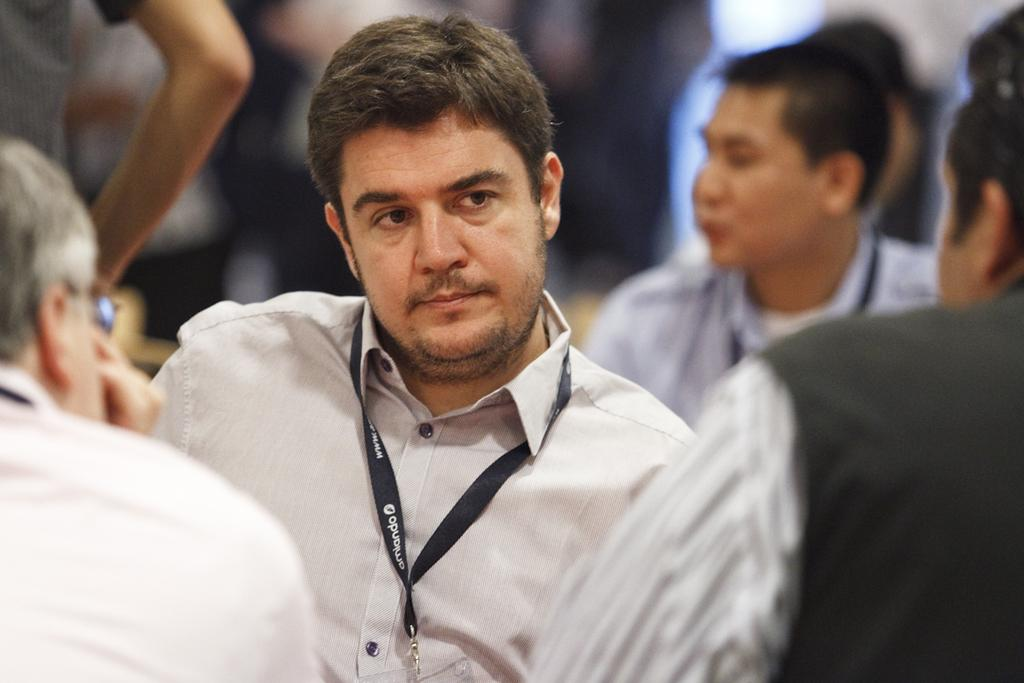How many individuals are present in the image? There is a group of people in the image. What type of liquid is being served at the party in the image? There is no party or liquid present in the image; it only shows a group of people. 